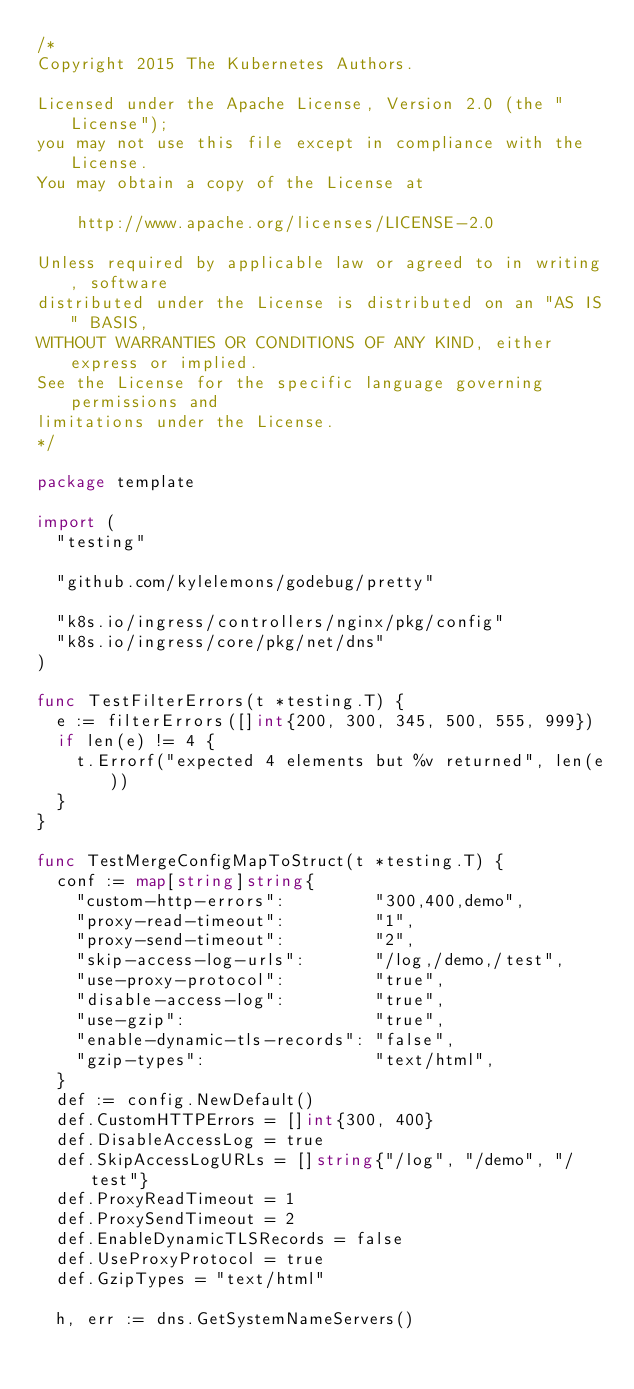Convert code to text. <code><loc_0><loc_0><loc_500><loc_500><_Go_>/*
Copyright 2015 The Kubernetes Authors.

Licensed under the Apache License, Version 2.0 (the "License");
you may not use this file except in compliance with the License.
You may obtain a copy of the License at

    http://www.apache.org/licenses/LICENSE-2.0

Unless required by applicable law or agreed to in writing, software
distributed under the License is distributed on an "AS IS" BASIS,
WITHOUT WARRANTIES OR CONDITIONS OF ANY KIND, either express or implied.
See the License for the specific language governing permissions and
limitations under the License.
*/

package template

import (
	"testing"

	"github.com/kylelemons/godebug/pretty"

	"k8s.io/ingress/controllers/nginx/pkg/config"
	"k8s.io/ingress/core/pkg/net/dns"
)

func TestFilterErrors(t *testing.T) {
	e := filterErrors([]int{200, 300, 345, 500, 555, 999})
	if len(e) != 4 {
		t.Errorf("expected 4 elements but %v returned", len(e))
	}
}

func TestMergeConfigMapToStruct(t *testing.T) {
	conf := map[string]string{
		"custom-http-errors":         "300,400,demo",
		"proxy-read-timeout":         "1",
		"proxy-send-timeout":         "2",
		"skip-access-log-urls":       "/log,/demo,/test",
		"use-proxy-protocol":         "true",
		"disable-access-log":         "true",
		"use-gzip":                   "true",
		"enable-dynamic-tls-records": "false",
		"gzip-types":                 "text/html",
	}
	def := config.NewDefault()
	def.CustomHTTPErrors = []int{300, 400}
	def.DisableAccessLog = true
	def.SkipAccessLogURLs = []string{"/log", "/demo", "/test"}
	def.ProxyReadTimeout = 1
	def.ProxySendTimeout = 2
	def.EnableDynamicTLSRecords = false
	def.UseProxyProtocol = true
	def.GzipTypes = "text/html"

	h, err := dns.GetSystemNameServers()</code> 